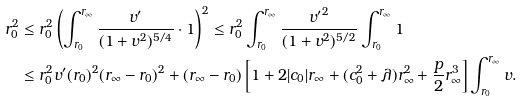<formula> <loc_0><loc_0><loc_500><loc_500>r _ { 0 } ^ { 2 } & \leq r _ { 0 } ^ { 2 } \left ( \int _ { r _ { 0 } } ^ { r _ { \infty } } \frac { v ^ { \prime } } { ( 1 + v ^ { 2 } ) ^ { 5 / 4 } } \cdot 1 \right ) ^ { 2 } \leq r _ { 0 } ^ { 2 } \int _ { r _ { 0 } } ^ { r _ { \infty } } \frac { { v ^ { \prime } } ^ { 2 } } { ( 1 + v ^ { 2 } ) ^ { 5 / 2 } } \int _ { r _ { 0 } } ^ { r _ { \infty } } 1 \\ & \leq r _ { 0 } ^ { 2 } v ^ { \prime } ( r _ { 0 } ) ^ { 2 } ( r _ { \infty } - r _ { 0 } ) ^ { 2 } + ( r _ { \infty } - r _ { 0 } ) \left [ 1 + 2 | c _ { 0 } | r _ { \infty } + ( c _ { 0 } ^ { 2 } + \lambda ) r _ { \infty } ^ { 2 } + \frac { p } { 2 } r _ { \infty } ^ { 3 } \right ] \int _ { r _ { 0 } } ^ { r _ { \infty } } v .</formula> 